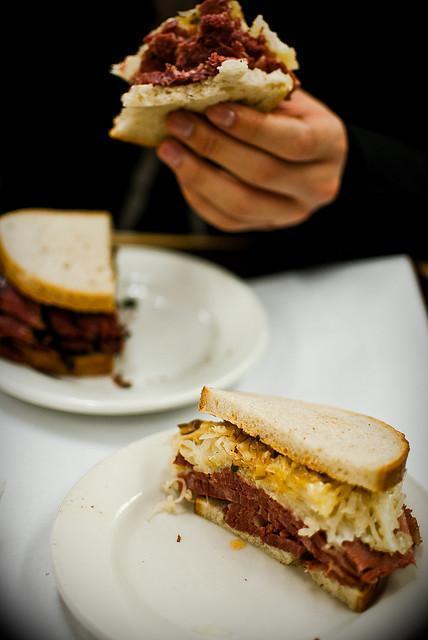How many digits are making contact with the food item?
Give a very brief answer. 5. How many sandwiches are there?
Give a very brief answer. 3. 